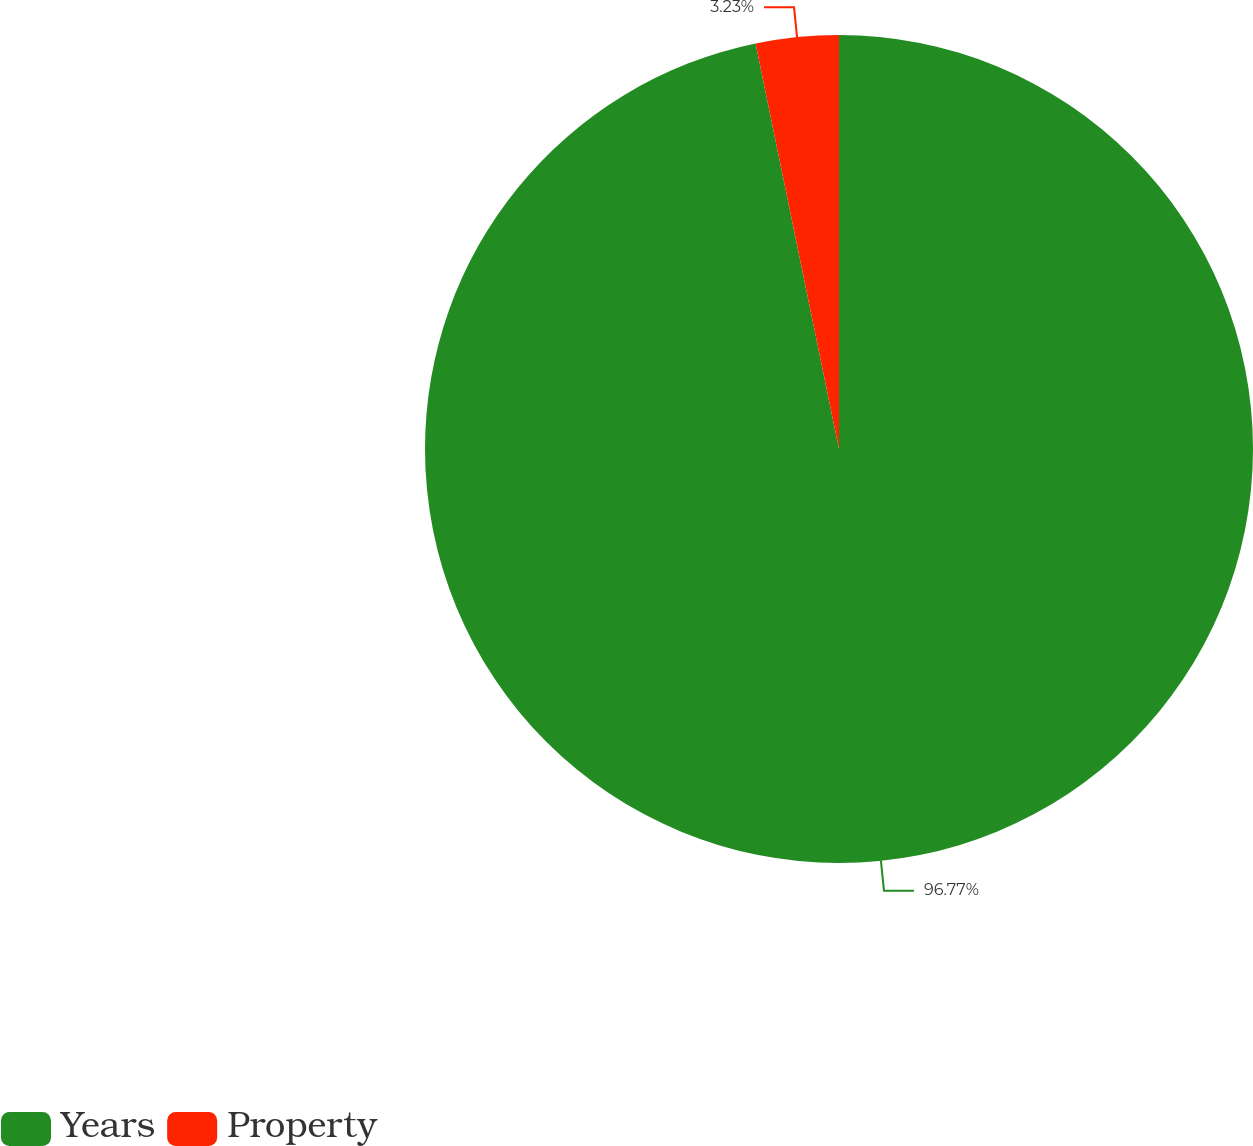Convert chart. <chart><loc_0><loc_0><loc_500><loc_500><pie_chart><fcel>Years<fcel>Property<nl><fcel>96.77%<fcel>3.23%<nl></chart> 